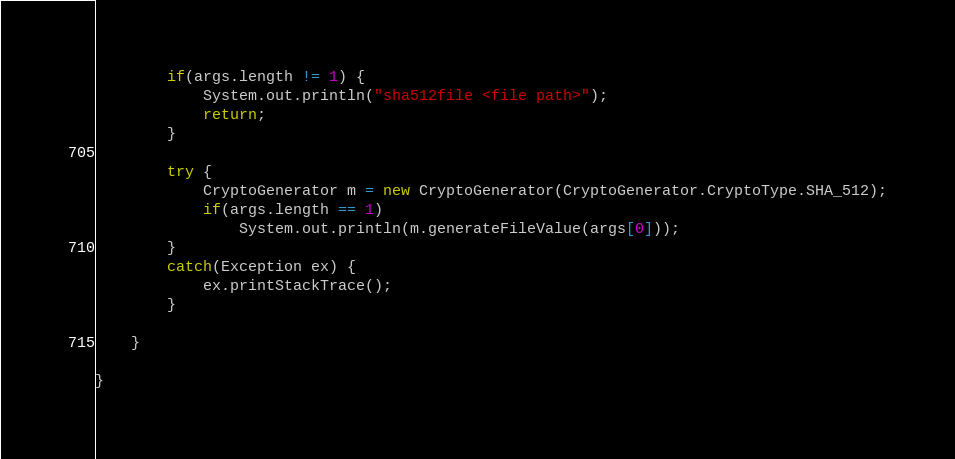Convert code to text. <code><loc_0><loc_0><loc_500><loc_500><_Java_>		if(args.length != 1) {
			System.out.println("sha512file <file path>");
			return;
		}
		
		try {
			CryptoGenerator m = new CryptoGenerator(CryptoGenerator.CryptoType.SHA_512);
			if(args.length == 1) 
				System.out.println(m.generateFileValue(args[0]));
		}
		catch(Exception ex) {
			ex.printStackTrace();
		}

	}

}
</code> 